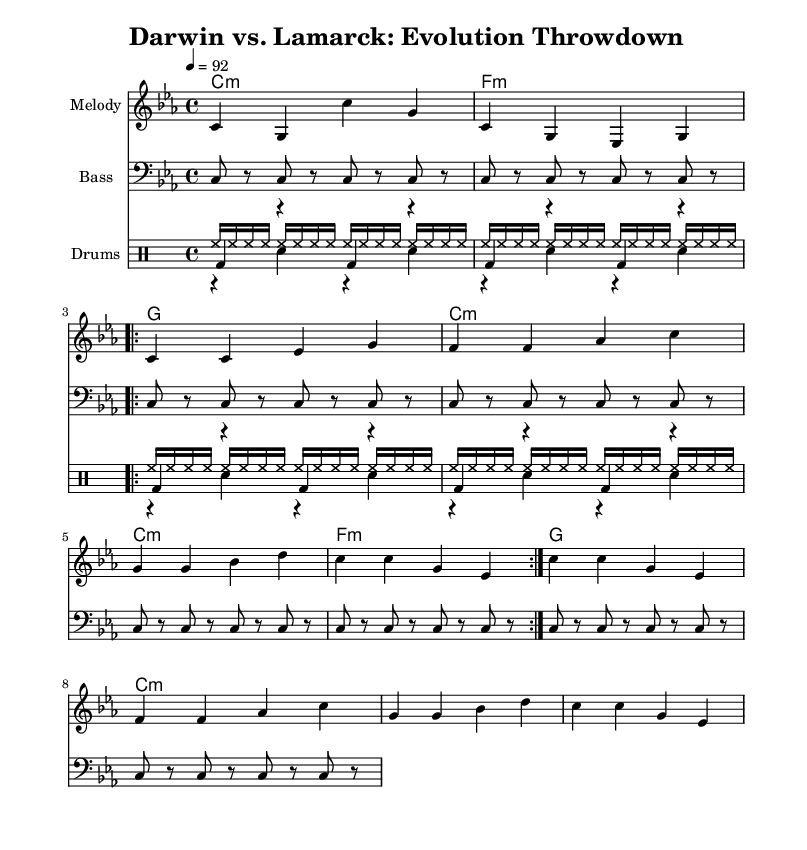What is the key signature of this music? The key signature is C minor, which includes three flats (B-flat, E-flat, and A-flat).
Answer: C minor What is the time signature of this music? The time signature is 4/4, which means there are four beats in each measure and the quarter note gets one beat.
Answer: 4/4 What is the tempo marking for this piece? The tempo marking is 92 beats per minute, indicating how fast the piece should be played.
Answer: 92 How many times is the verse repeated? The verse section is repeated two times, as indicated by the "repeat volta" marking.
Answer: 2 What is the name of the first chord in the chord progression? The first chord shown in the progression is C minor, as indicated at the start of the progression.
Answer: C minor What type of music is this piece specifically categorized under? This piece is categorized as a rap-themed composition, evident from the style and context of the lyrics associated with famous biologists.
Answer: Rap How many measures are in the chorus section? The chorus section consists of four measures, as it is presented in a continuous block without additional repeats.
Answer: 4 